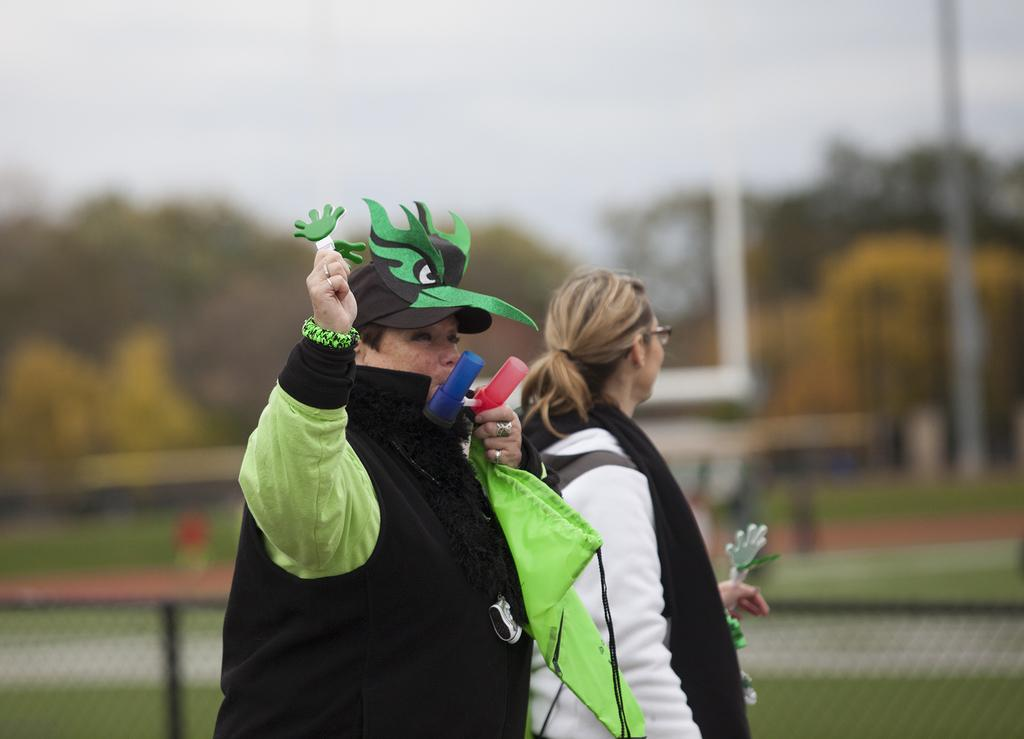How many people are in the center of the picture? There are two women in the center of the picture. What can be observed about the background of the image? The background is blurred. What type of natural environment is visible in the background? There is greenery in the background of the image. What type of process is being carried out by the bears in the image? There are no bears present in the image, so no process being carried out by bears. What symbolizes peace in the image? There is no symbol of peace present in the image. 